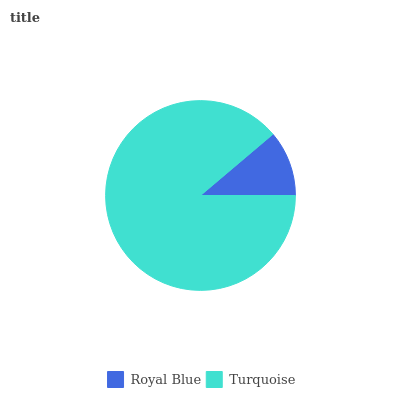Is Royal Blue the minimum?
Answer yes or no. Yes. Is Turquoise the maximum?
Answer yes or no. Yes. Is Turquoise the minimum?
Answer yes or no. No. Is Turquoise greater than Royal Blue?
Answer yes or no. Yes. Is Royal Blue less than Turquoise?
Answer yes or no. Yes. Is Royal Blue greater than Turquoise?
Answer yes or no. No. Is Turquoise less than Royal Blue?
Answer yes or no. No. Is Turquoise the high median?
Answer yes or no. Yes. Is Royal Blue the low median?
Answer yes or no. Yes. Is Royal Blue the high median?
Answer yes or no. No. Is Turquoise the low median?
Answer yes or no. No. 